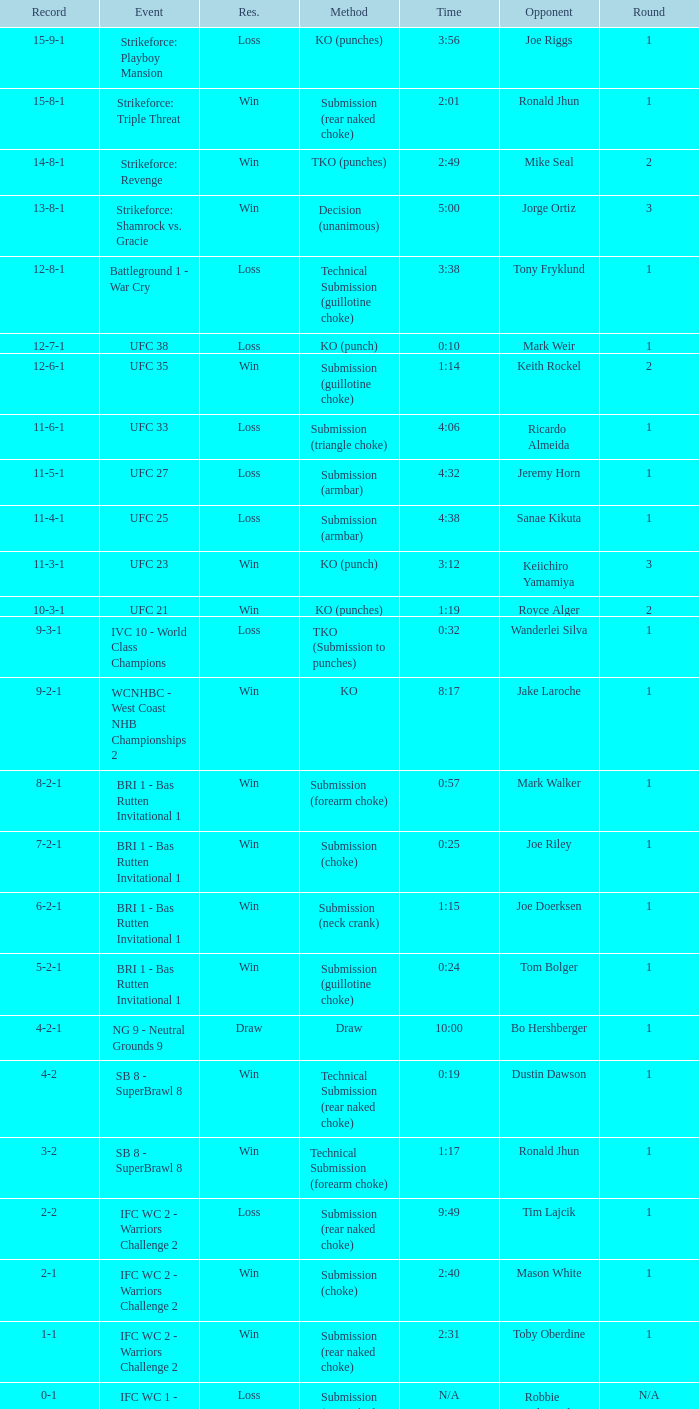What is the record when the fight was against keith rockel? 12-6-1. 